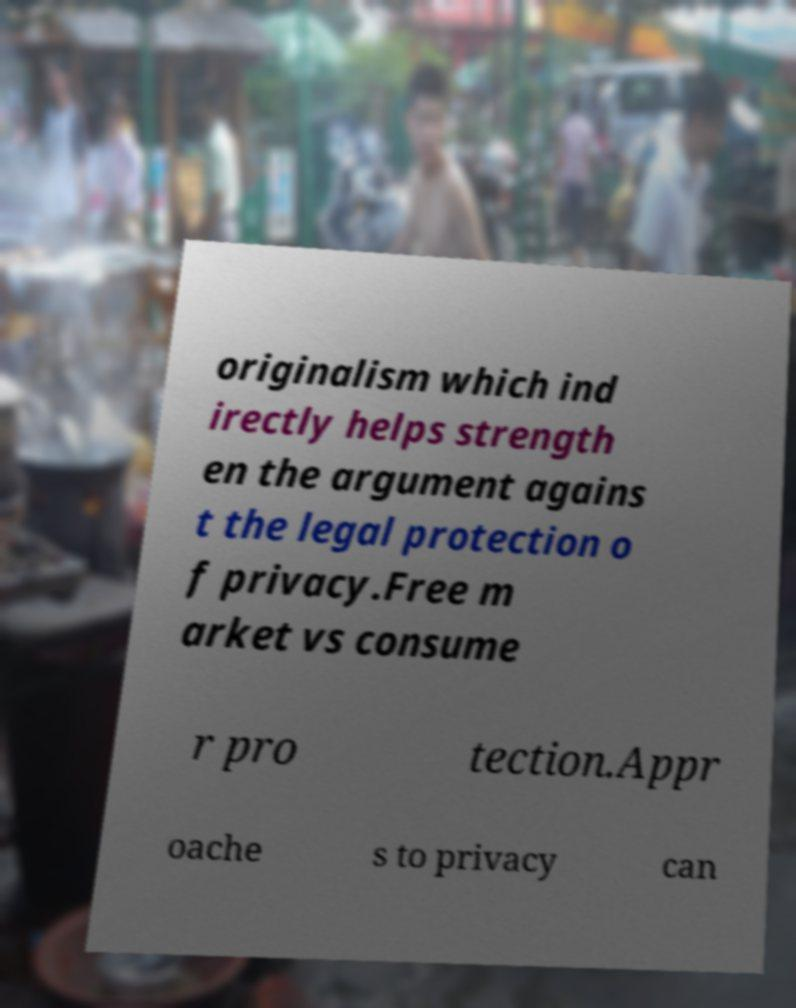Please identify and transcribe the text found in this image. originalism which ind irectly helps strength en the argument agains t the legal protection o f privacy.Free m arket vs consume r pro tection.Appr oache s to privacy can 